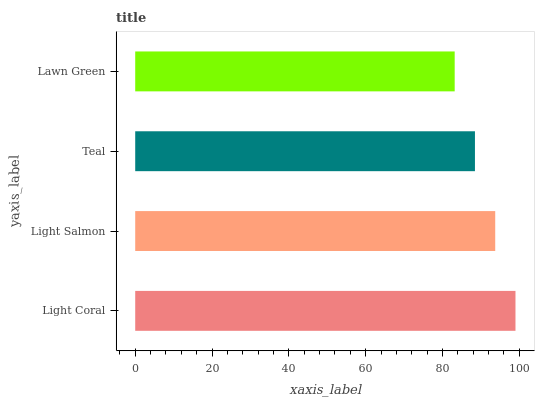Is Lawn Green the minimum?
Answer yes or no. Yes. Is Light Coral the maximum?
Answer yes or no. Yes. Is Light Salmon the minimum?
Answer yes or no. No. Is Light Salmon the maximum?
Answer yes or no. No. Is Light Coral greater than Light Salmon?
Answer yes or no. Yes. Is Light Salmon less than Light Coral?
Answer yes or no. Yes. Is Light Salmon greater than Light Coral?
Answer yes or no. No. Is Light Coral less than Light Salmon?
Answer yes or no. No. Is Light Salmon the high median?
Answer yes or no. Yes. Is Teal the low median?
Answer yes or no. Yes. Is Teal the high median?
Answer yes or no. No. Is Light Salmon the low median?
Answer yes or no. No. 